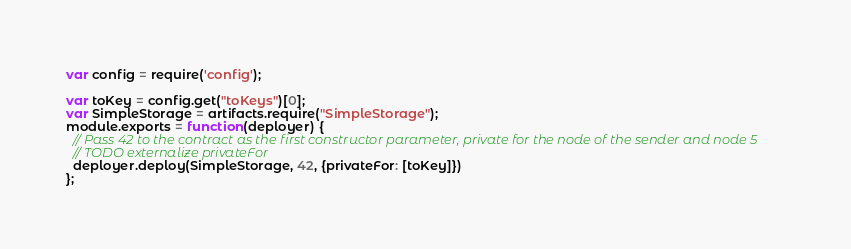<code> <loc_0><loc_0><loc_500><loc_500><_JavaScript_>var config = require('config');

var toKey = config.get("toKeys")[0]; 
var SimpleStorage = artifacts.require("SimpleStorage");
module.exports = function(deployer) {
  // Pass 42 to the contract as the first constructor parameter, private for the node of the sender and node 5
  // TODO externalize privateFor
  deployer.deploy(SimpleStorage, 42, {privateFor: [toKey]})
};
</code> 